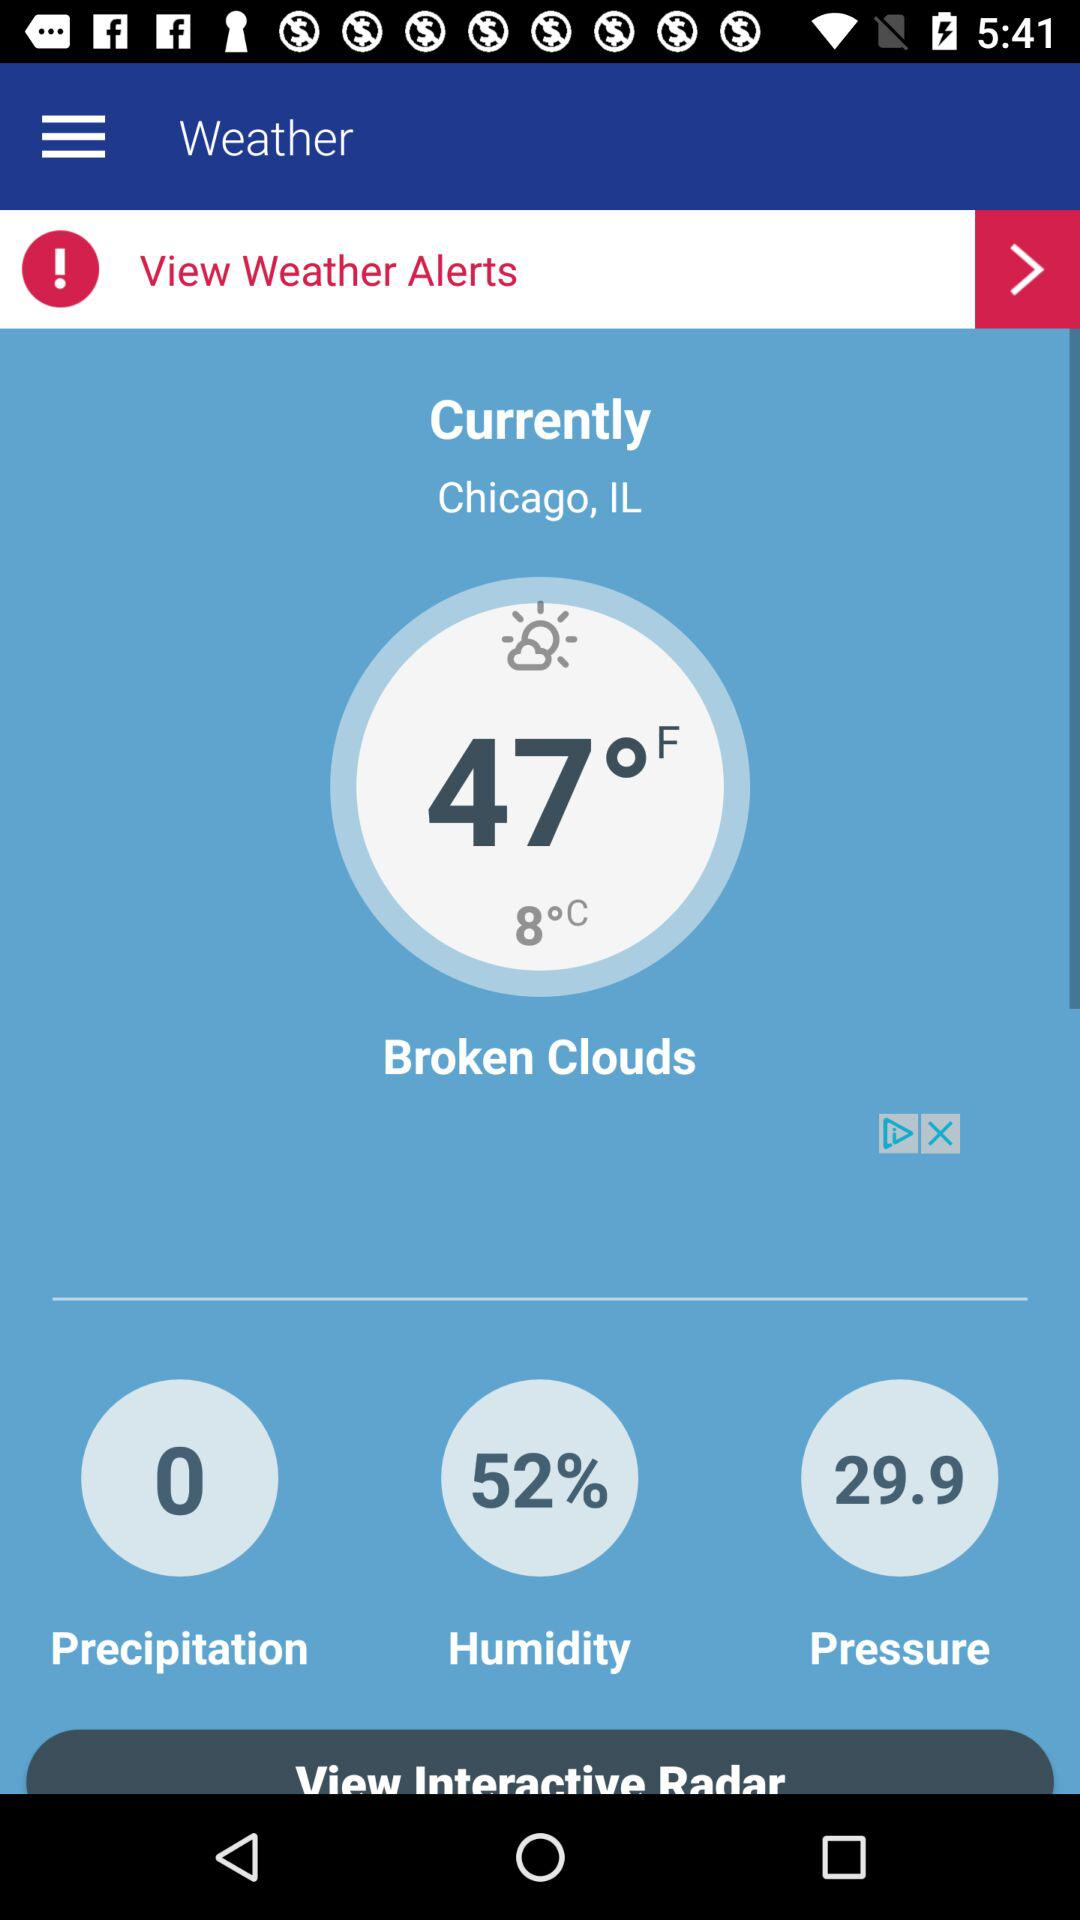What is the humidity percentage?
Answer the question using a single word or phrase. 52% 